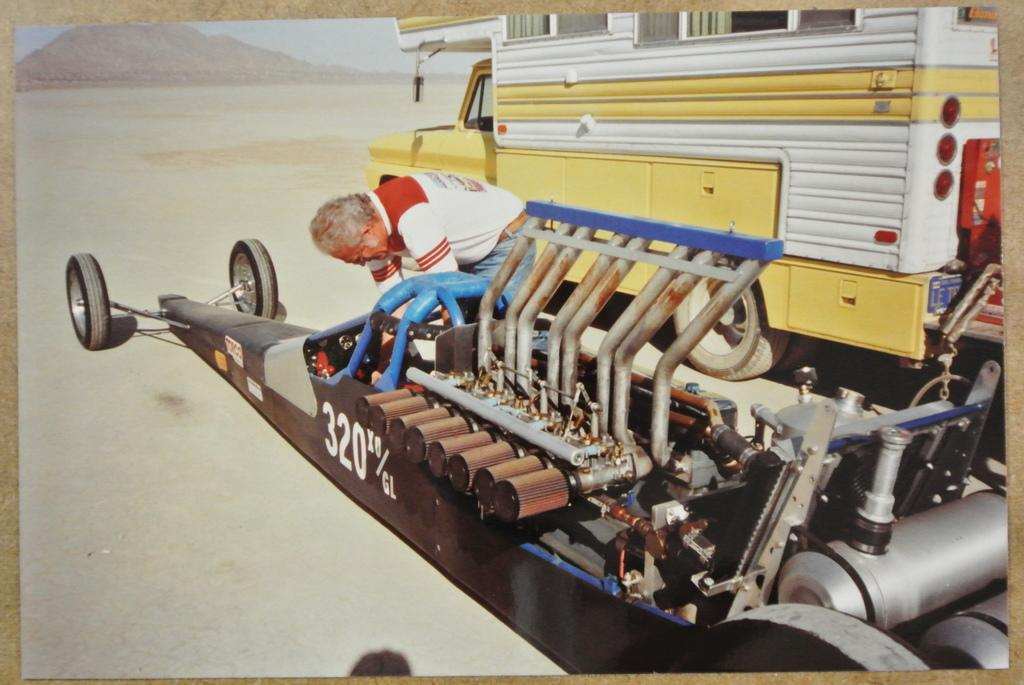What is the main subject in the foreground of the image? There is a machine that looks like a car in the foreground of the image. Can you describe the person in the image? There is a person in the center of the image. What other vehicle can be seen in the image? There is a van at the top of the image. What type of landscape is visible in the background? There is a hill in the background of the image. What type of voyage is the person embarking on in the image? There is no indication of a voyage in the image; it simply shows a person, a car-like machine, a van, and a hill in the background. Can you describe the flight path of the airplane in the image? There is no airplane present in the image. 